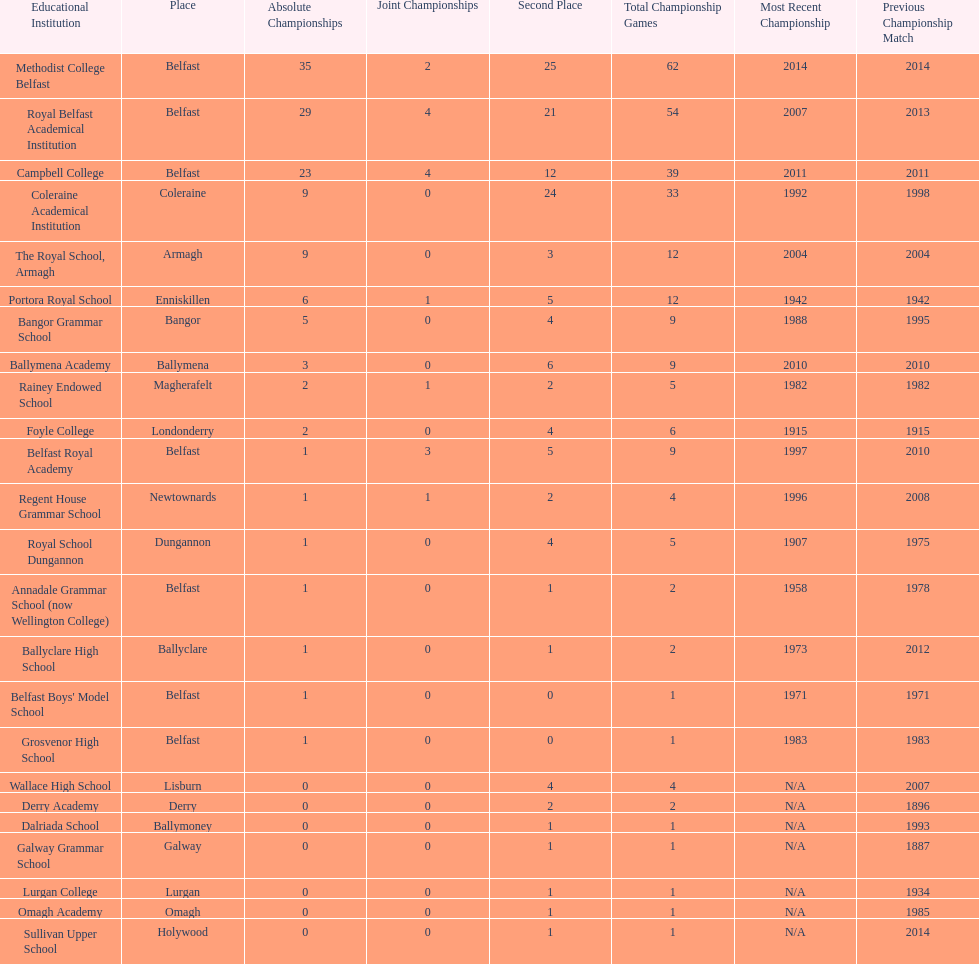Parse the full table. {'header': ['Educational Institution', 'Place', 'Absolute Championships', 'Joint Championships', 'Second Place', 'Total Championship Games', 'Most Recent Championship', 'Previous Championship Match'], 'rows': [['Methodist College Belfast', 'Belfast', '35', '2', '25', '62', '2014', '2014'], ['Royal Belfast Academical Institution', 'Belfast', '29', '4', '21', '54', '2007', '2013'], ['Campbell College', 'Belfast', '23', '4', '12', '39', '2011', '2011'], ['Coleraine Academical Institution', 'Coleraine', '9', '0', '24', '33', '1992', '1998'], ['The Royal School, Armagh', 'Armagh', '9', '0', '3', '12', '2004', '2004'], ['Portora Royal School', 'Enniskillen', '6', '1', '5', '12', '1942', '1942'], ['Bangor Grammar School', 'Bangor', '5', '0', '4', '9', '1988', '1995'], ['Ballymena Academy', 'Ballymena', '3', '0', '6', '9', '2010', '2010'], ['Rainey Endowed School', 'Magherafelt', '2', '1', '2', '5', '1982', '1982'], ['Foyle College', 'Londonderry', '2', '0', '4', '6', '1915', '1915'], ['Belfast Royal Academy', 'Belfast', '1', '3', '5', '9', '1997', '2010'], ['Regent House Grammar School', 'Newtownards', '1', '1', '2', '4', '1996', '2008'], ['Royal School Dungannon', 'Dungannon', '1', '0', '4', '5', '1907', '1975'], ['Annadale Grammar School (now Wellington College)', 'Belfast', '1', '0', '1', '2', '1958', '1978'], ['Ballyclare High School', 'Ballyclare', '1', '0', '1', '2', '1973', '2012'], ["Belfast Boys' Model School", 'Belfast', '1', '0', '0', '1', '1971', '1971'], ['Grosvenor High School', 'Belfast', '1', '0', '0', '1', '1983', '1983'], ['Wallace High School', 'Lisburn', '0', '0', '4', '4', 'N/A', '2007'], ['Derry Academy', 'Derry', '0', '0', '2', '2', 'N/A', '1896'], ['Dalriada School', 'Ballymoney', '0', '0', '1', '1', 'N/A', '1993'], ['Galway Grammar School', 'Galway', '0', '0', '1', '1', 'N/A', '1887'], ['Lurgan College', 'Lurgan', '0', '0', '1', '1', 'N/A', '1934'], ['Omagh Academy', 'Omagh', '0', '0', '1', '1', 'N/A', '1985'], ['Sullivan Upper School', 'Holywood', '0', '0', '1', '1', 'N/A', '2014']]} Which school has the same number of outright titles as the coleraine academical institution? The Royal School, Armagh. 